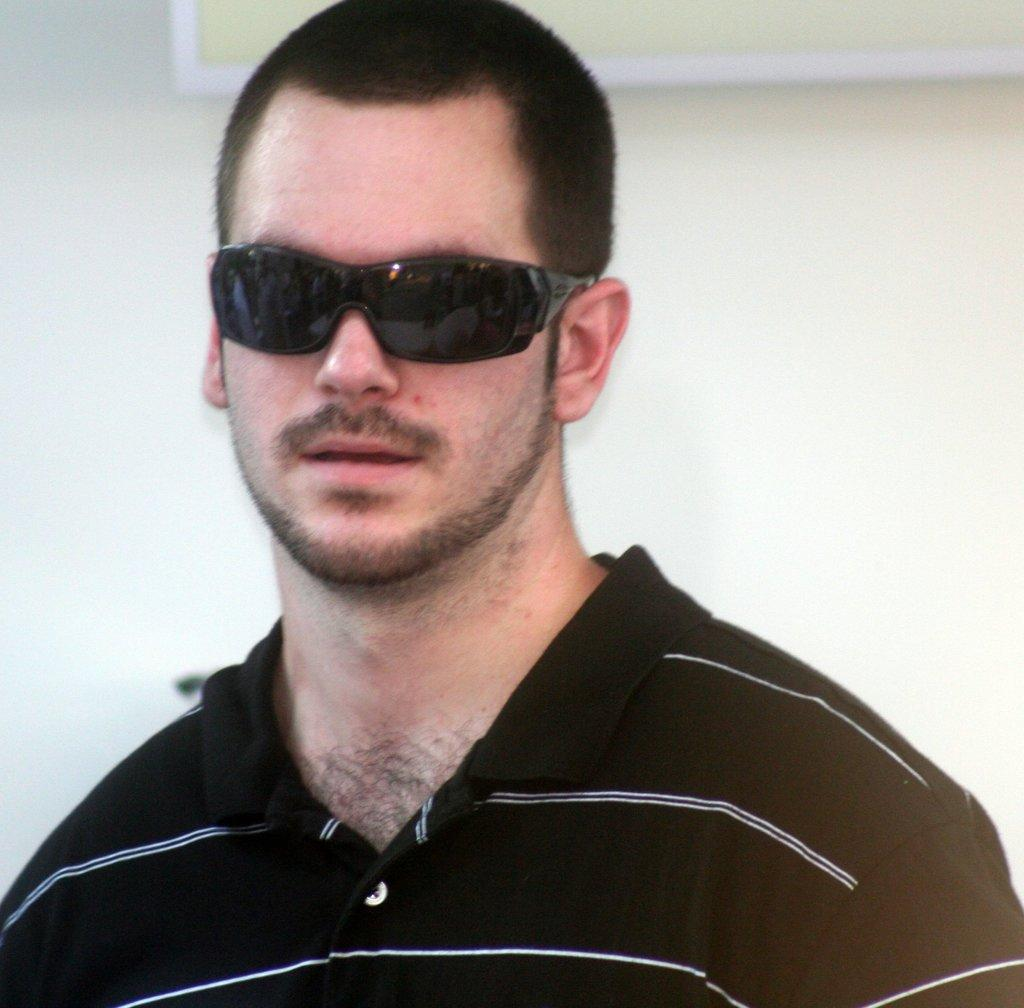Who or what is present in the image? There is a person in the image. What is the person doing in the image? The person is standing on the floor. What is the person wearing on their upper body? The person is wearing a black color T-shirt. What type of protective eyewear is the person wearing? The person is wearing goggles. Where can the flock of geese be seen in the image? There is no flock of geese present in the image. What type of transportation is available at the airport in the image? There is no airport present in the image. 